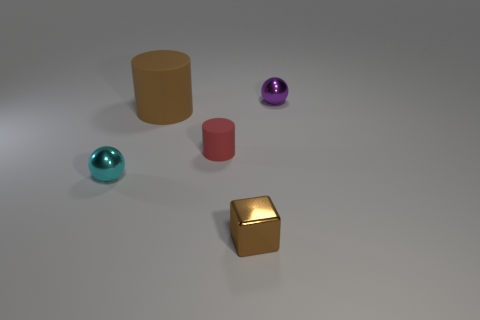Add 1 small balls. How many objects exist? 6 Add 5 red cylinders. How many red cylinders are left? 6 Add 1 purple rubber blocks. How many purple rubber blocks exist? 1 Subtract 0 purple cylinders. How many objects are left? 5 Subtract all cubes. How many objects are left? 4 Subtract all tiny purple rubber things. Subtract all red cylinders. How many objects are left? 4 